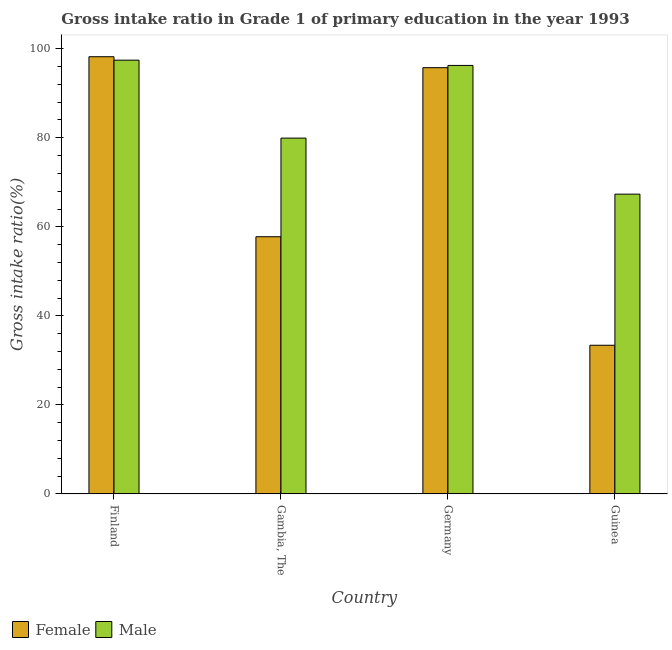How many different coloured bars are there?
Offer a terse response. 2. How many bars are there on the 1st tick from the right?
Your response must be concise. 2. In how many cases, is the number of bars for a given country not equal to the number of legend labels?
Offer a terse response. 0. What is the gross intake ratio(female) in Finland?
Provide a short and direct response. 98.21. Across all countries, what is the maximum gross intake ratio(male)?
Your answer should be compact. 97.44. Across all countries, what is the minimum gross intake ratio(female)?
Offer a very short reply. 33.39. In which country was the gross intake ratio(male) maximum?
Offer a very short reply. Finland. In which country was the gross intake ratio(male) minimum?
Offer a terse response. Guinea. What is the total gross intake ratio(male) in the graph?
Provide a short and direct response. 340.96. What is the difference between the gross intake ratio(male) in Gambia, The and that in Guinea?
Offer a very short reply. 12.6. What is the difference between the gross intake ratio(female) in Germany and the gross intake ratio(male) in Finland?
Offer a terse response. -1.69. What is the average gross intake ratio(male) per country?
Make the answer very short. 85.24. What is the difference between the gross intake ratio(male) and gross intake ratio(female) in Guinea?
Provide a succinct answer. 33.95. In how many countries, is the gross intake ratio(female) greater than 8 %?
Provide a succinct answer. 4. What is the ratio of the gross intake ratio(female) in Finland to that in Gambia, The?
Provide a short and direct response. 1.7. Is the gross intake ratio(male) in Gambia, The less than that in Germany?
Ensure brevity in your answer.  Yes. Is the difference between the gross intake ratio(male) in Gambia, The and Germany greater than the difference between the gross intake ratio(female) in Gambia, The and Germany?
Make the answer very short. Yes. What is the difference between the highest and the second highest gross intake ratio(male)?
Your answer should be very brief. 1.18. What is the difference between the highest and the lowest gross intake ratio(male)?
Make the answer very short. 30.1. In how many countries, is the gross intake ratio(male) greater than the average gross intake ratio(male) taken over all countries?
Offer a terse response. 2. Is the sum of the gross intake ratio(female) in Gambia, The and Germany greater than the maximum gross intake ratio(male) across all countries?
Your answer should be very brief. Yes. How many bars are there?
Your answer should be compact. 8. How many countries are there in the graph?
Provide a succinct answer. 4. What is the difference between two consecutive major ticks on the Y-axis?
Provide a short and direct response. 20. Are the values on the major ticks of Y-axis written in scientific E-notation?
Offer a very short reply. No. How many legend labels are there?
Provide a succinct answer. 2. What is the title of the graph?
Your answer should be compact. Gross intake ratio in Grade 1 of primary education in the year 1993. What is the label or title of the Y-axis?
Offer a terse response. Gross intake ratio(%). What is the Gross intake ratio(%) of Female in Finland?
Ensure brevity in your answer.  98.21. What is the Gross intake ratio(%) of Male in Finland?
Keep it short and to the point. 97.44. What is the Gross intake ratio(%) of Female in Gambia, The?
Ensure brevity in your answer.  57.77. What is the Gross intake ratio(%) of Male in Gambia, The?
Offer a very short reply. 79.93. What is the Gross intake ratio(%) of Female in Germany?
Your answer should be very brief. 95.75. What is the Gross intake ratio(%) in Male in Germany?
Provide a short and direct response. 96.26. What is the Gross intake ratio(%) of Female in Guinea?
Keep it short and to the point. 33.39. What is the Gross intake ratio(%) in Male in Guinea?
Keep it short and to the point. 67.34. Across all countries, what is the maximum Gross intake ratio(%) of Female?
Offer a very short reply. 98.21. Across all countries, what is the maximum Gross intake ratio(%) in Male?
Offer a very short reply. 97.44. Across all countries, what is the minimum Gross intake ratio(%) of Female?
Give a very brief answer. 33.39. Across all countries, what is the minimum Gross intake ratio(%) of Male?
Keep it short and to the point. 67.34. What is the total Gross intake ratio(%) of Female in the graph?
Make the answer very short. 285.12. What is the total Gross intake ratio(%) in Male in the graph?
Your response must be concise. 340.96. What is the difference between the Gross intake ratio(%) in Female in Finland and that in Gambia, The?
Provide a short and direct response. 40.44. What is the difference between the Gross intake ratio(%) of Male in Finland and that in Gambia, The?
Keep it short and to the point. 17.51. What is the difference between the Gross intake ratio(%) of Female in Finland and that in Germany?
Provide a short and direct response. 2.46. What is the difference between the Gross intake ratio(%) of Male in Finland and that in Germany?
Give a very brief answer. 1.18. What is the difference between the Gross intake ratio(%) of Female in Finland and that in Guinea?
Provide a short and direct response. 64.82. What is the difference between the Gross intake ratio(%) in Male in Finland and that in Guinea?
Ensure brevity in your answer.  30.1. What is the difference between the Gross intake ratio(%) of Female in Gambia, The and that in Germany?
Provide a succinct answer. -37.98. What is the difference between the Gross intake ratio(%) of Male in Gambia, The and that in Germany?
Ensure brevity in your answer.  -16.33. What is the difference between the Gross intake ratio(%) in Female in Gambia, The and that in Guinea?
Your answer should be compact. 24.38. What is the difference between the Gross intake ratio(%) in Male in Gambia, The and that in Guinea?
Your response must be concise. 12.6. What is the difference between the Gross intake ratio(%) of Female in Germany and that in Guinea?
Keep it short and to the point. 62.36. What is the difference between the Gross intake ratio(%) in Male in Germany and that in Guinea?
Offer a terse response. 28.92. What is the difference between the Gross intake ratio(%) in Female in Finland and the Gross intake ratio(%) in Male in Gambia, The?
Provide a short and direct response. 18.28. What is the difference between the Gross intake ratio(%) in Female in Finland and the Gross intake ratio(%) in Male in Germany?
Ensure brevity in your answer.  1.95. What is the difference between the Gross intake ratio(%) of Female in Finland and the Gross intake ratio(%) of Male in Guinea?
Ensure brevity in your answer.  30.88. What is the difference between the Gross intake ratio(%) of Female in Gambia, The and the Gross intake ratio(%) of Male in Germany?
Ensure brevity in your answer.  -38.49. What is the difference between the Gross intake ratio(%) in Female in Gambia, The and the Gross intake ratio(%) in Male in Guinea?
Provide a short and direct response. -9.57. What is the difference between the Gross intake ratio(%) in Female in Germany and the Gross intake ratio(%) in Male in Guinea?
Your response must be concise. 28.42. What is the average Gross intake ratio(%) in Female per country?
Your response must be concise. 71.28. What is the average Gross intake ratio(%) in Male per country?
Offer a very short reply. 85.24. What is the difference between the Gross intake ratio(%) of Female and Gross intake ratio(%) of Male in Finland?
Offer a very short reply. 0.77. What is the difference between the Gross intake ratio(%) of Female and Gross intake ratio(%) of Male in Gambia, The?
Offer a very short reply. -22.16. What is the difference between the Gross intake ratio(%) of Female and Gross intake ratio(%) of Male in Germany?
Give a very brief answer. -0.51. What is the difference between the Gross intake ratio(%) of Female and Gross intake ratio(%) of Male in Guinea?
Offer a terse response. -33.95. What is the ratio of the Gross intake ratio(%) in Female in Finland to that in Gambia, The?
Make the answer very short. 1.7. What is the ratio of the Gross intake ratio(%) in Male in Finland to that in Gambia, The?
Your answer should be very brief. 1.22. What is the ratio of the Gross intake ratio(%) in Female in Finland to that in Germany?
Offer a terse response. 1.03. What is the ratio of the Gross intake ratio(%) in Male in Finland to that in Germany?
Your response must be concise. 1.01. What is the ratio of the Gross intake ratio(%) of Female in Finland to that in Guinea?
Ensure brevity in your answer.  2.94. What is the ratio of the Gross intake ratio(%) in Male in Finland to that in Guinea?
Provide a succinct answer. 1.45. What is the ratio of the Gross intake ratio(%) of Female in Gambia, The to that in Germany?
Provide a short and direct response. 0.6. What is the ratio of the Gross intake ratio(%) in Male in Gambia, The to that in Germany?
Offer a very short reply. 0.83. What is the ratio of the Gross intake ratio(%) in Female in Gambia, The to that in Guinea?
Your response must be concise. 1.73. What is the ratio of the Gross intake ratio(%) in Male in Gambia, The to that in Guinea?
Give a very brief answer. 1.19. What is the ratio of the Gross intake ratio(%) in Female in Germany to that in Guinea?
Offer a very short reply. 2.87. What is the ratio of the Gross intake ratio(%) of Male in Germany to that in Guinea?
Give a very brief answer. 1.43. What is the difference between the highest and the second highest Gross intake ratio(%) in Female?
Provide a short and direct response. 2.46. What is the difference between the highest and the second highest Gross intake ratio(%) of Male?
Your answer should be very brief. 1.18. What is the difference between the highest and the lowest Gross intake ratio(%) of Female?
Your answer should be compact. 64.82. What is the difference between the highest and the lowest Gross intake ratio(%) in Male?
Your response must be concise. 30.1. 